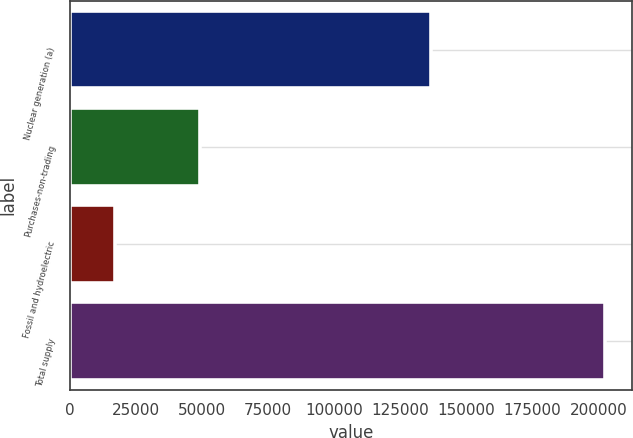<chart> <loc_0><loc_0><loc_500><loc_500><bar_chart><fcel>Nuclear generation (a)<fcel>Purchases-non-trading<fcel>Fossil and hydroelectric<fcel>Total supply<nl><fcel>136621<fcel>48968<fcel>17010<fcel>202599<nl></chart> 